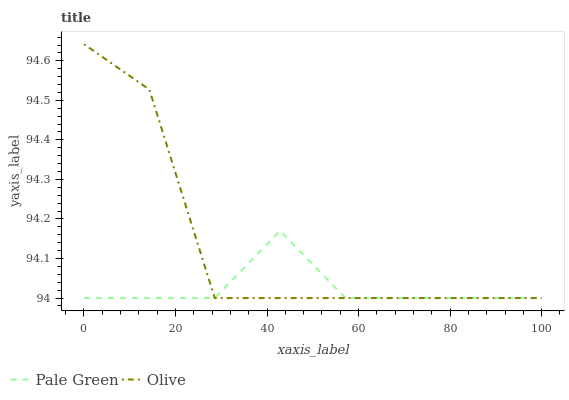Does Pale Green have the maximum area under the curve?
Answer yes or no. No. Is Pale Green the roughest?
Answer yes or no. No. Does Pale Green have the highest value?
Answer yes or no. No. 